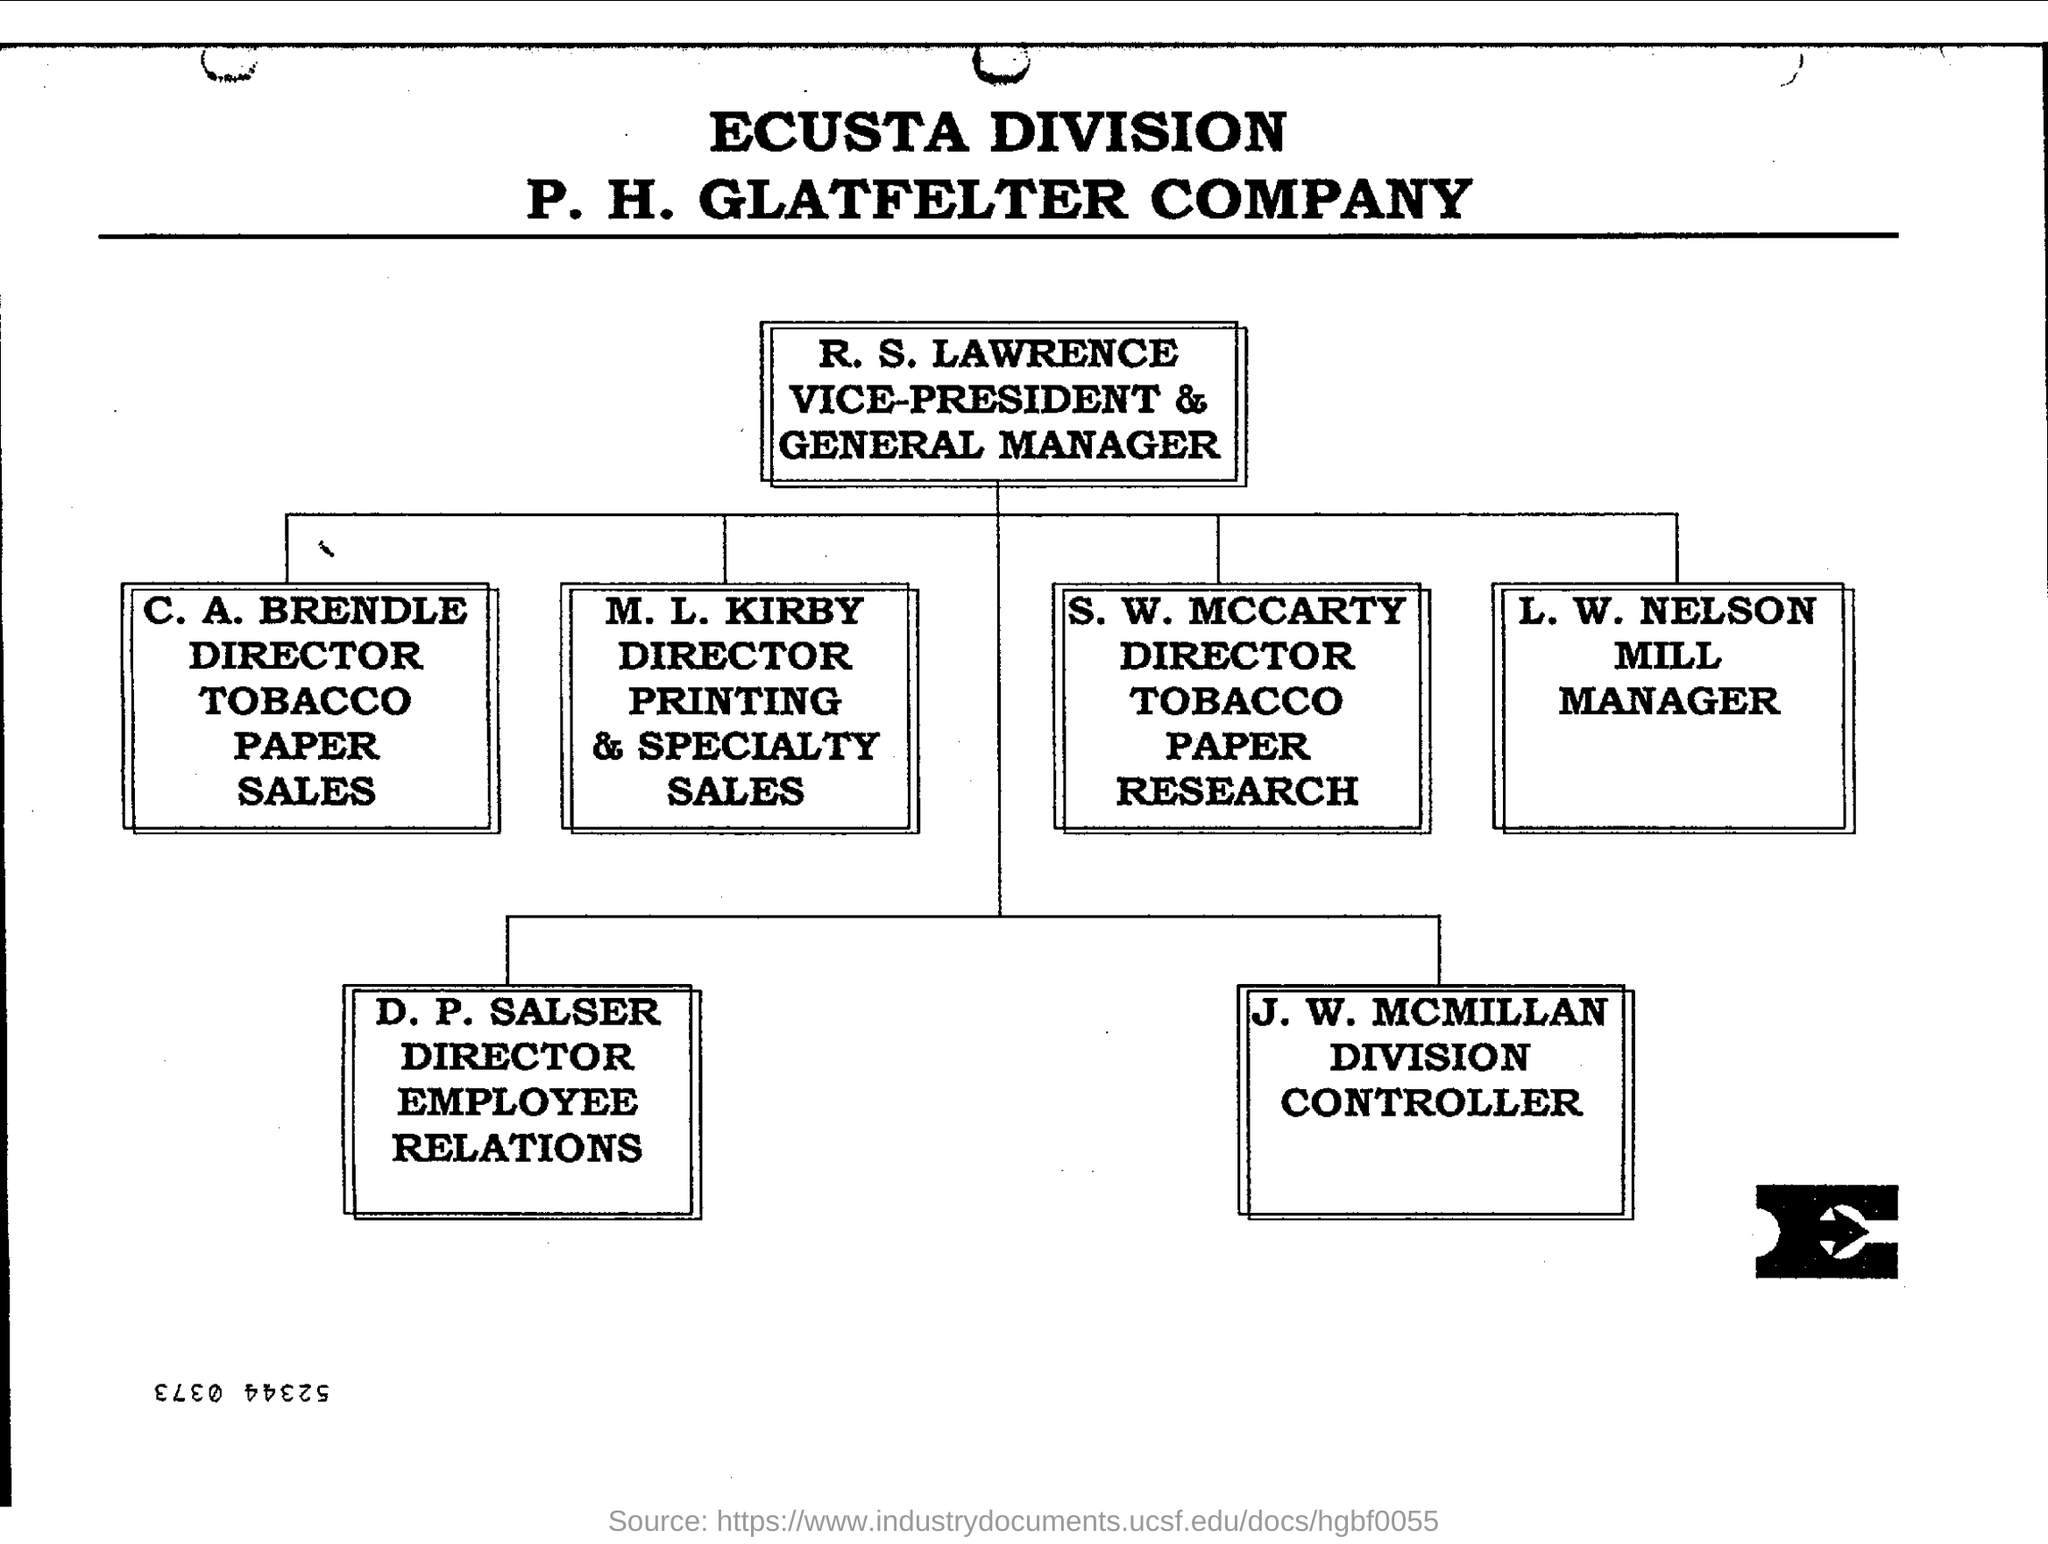Identify some key points in this picture. The company named in the document is P. H. Glatfelter. The person who is the mill manager is L. W. Nelson. 